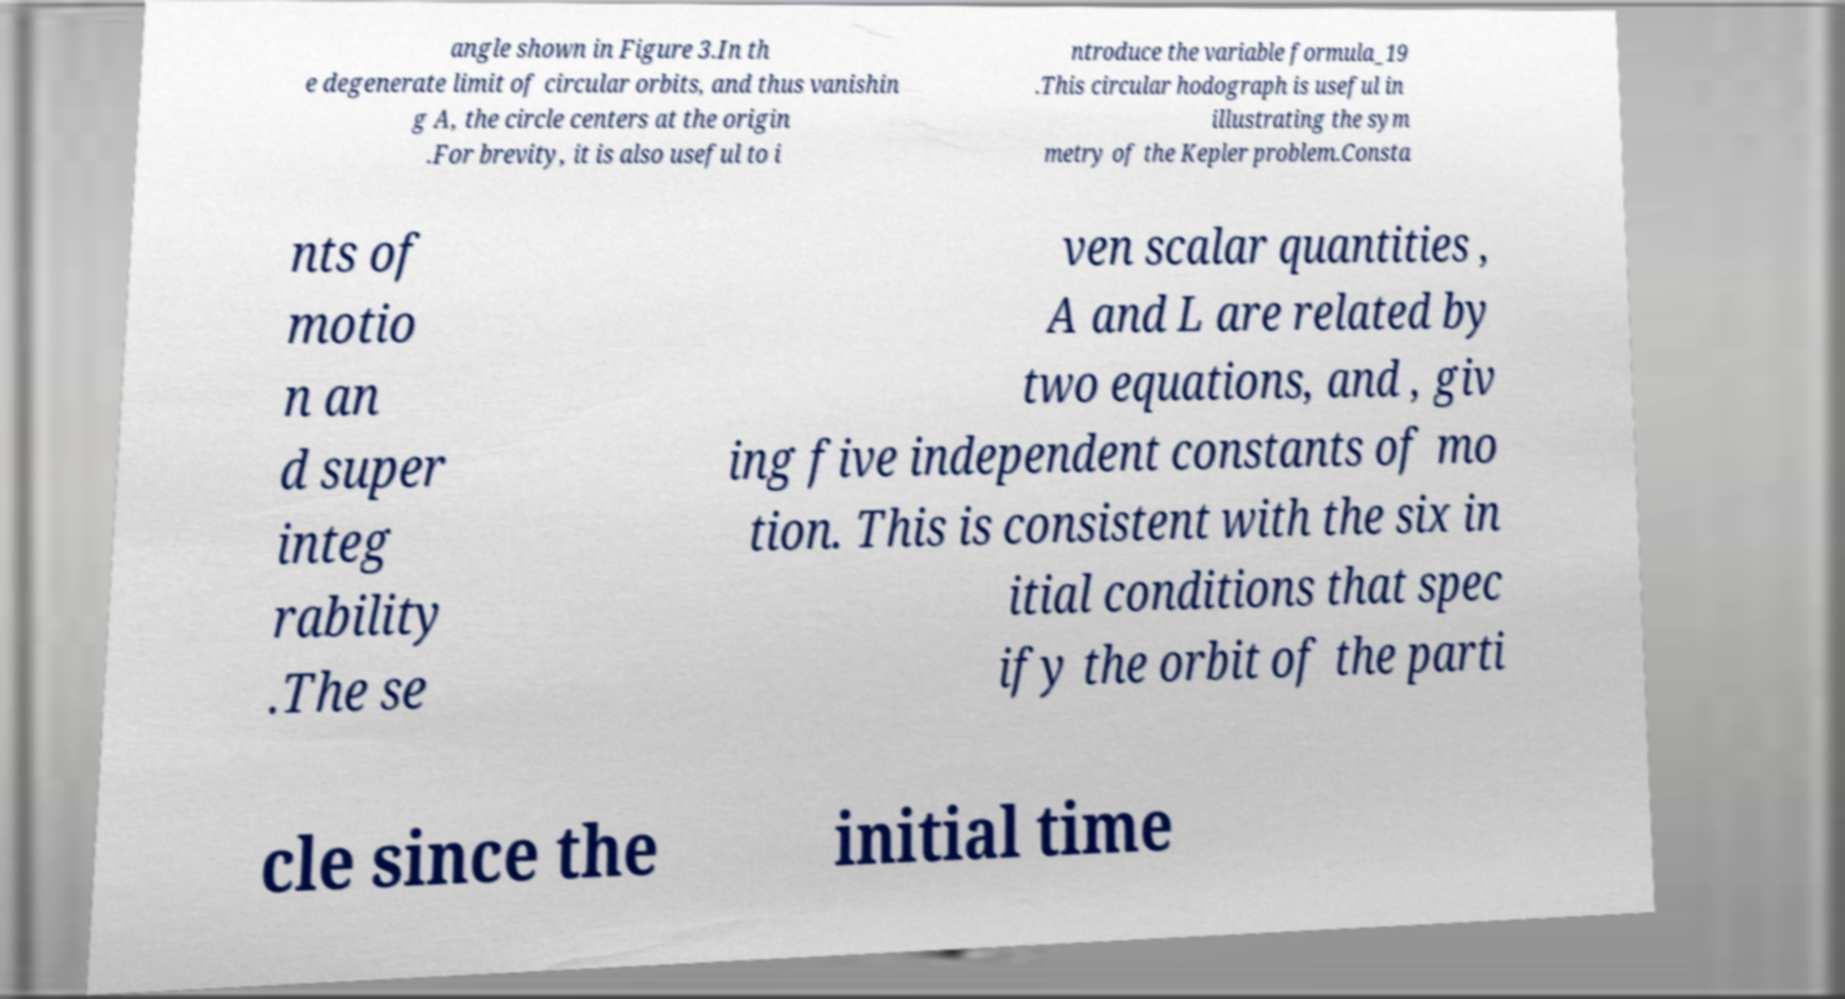Can you accurately transcribe the text from the provided image for me? angle shown in Figure 3.In th e degenerate limit of circular orbits, and thus vanishin g A, the circle centers at the origin .For brevity, it is also useful to i ntroduce the variable formula_19 .This circular hodograph is useful in illustrating the sym metry of the Kepler problem.Consta nts of motio n an d super integ rability .The se ven scalar quantities , A and L are related by two equations, and , giv ing five independent constants of mo tion. This is consistent with the six in itial conditions that spec ify the orbit of the parti cle since the initial time 